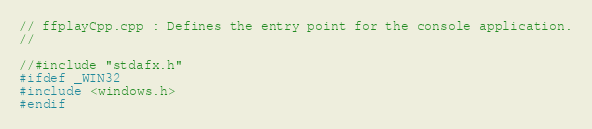<code> <loc_0><loc_0><loc_500><loc_500><_C++_>// ffplayCpp.cpp : Defines the entry point for the console application.
//

//#include "stdafx.h"
#ifdef _WIN32
#include <windows.h>
#endif
</code> 